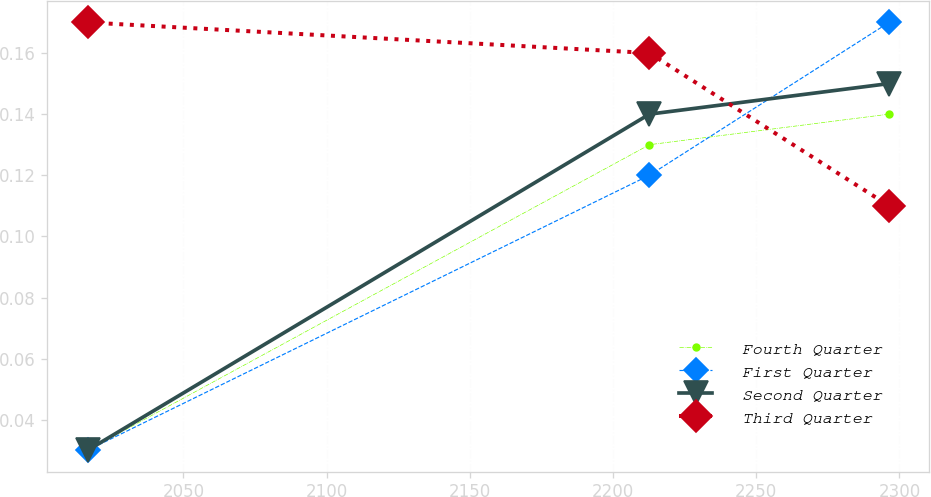<chart> <loc_0><loc_0><loc_500><loc_500><line_chart><ecel><fcel>Fourth Quarter<fcel>First Quarter<fcel>Second Quarter<fcel>Third Quarter<nl><fcel>2016.54<fcel>0.03<fcel>0.03<fcel>0.03<fcel>0.17<nl><fcel>2212.7<fcel>0.13<fcel>0.12<fcel>0.14<fcel>0.16<nl><fcel>2296.33<fcel>0.14<fcel>0.17<fcel>0.15<fcel>0.11<nl></chart> 